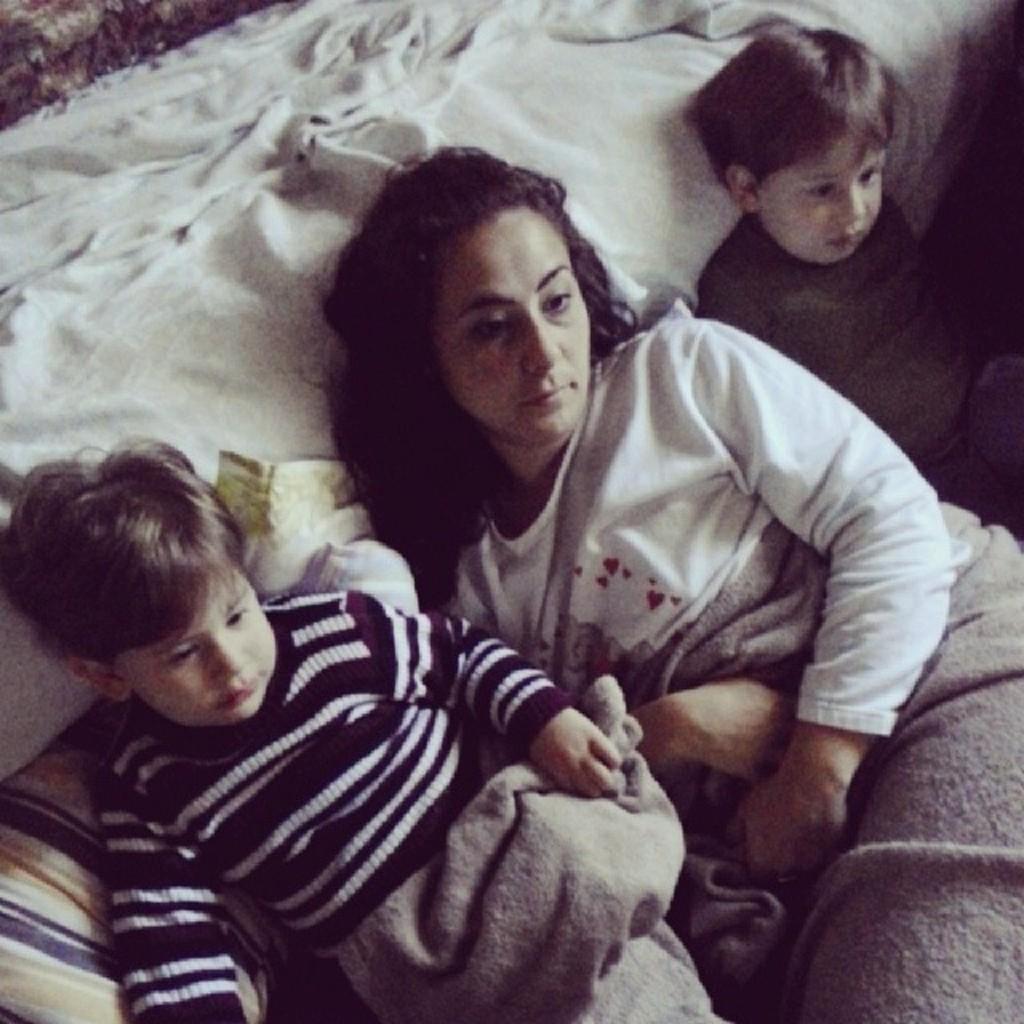Can you describe this image briefly? In this picture there is a bed, on the bed there is a woman and two kids sleeping. At the bottom there is a blanket. On the left there is a pillow. 